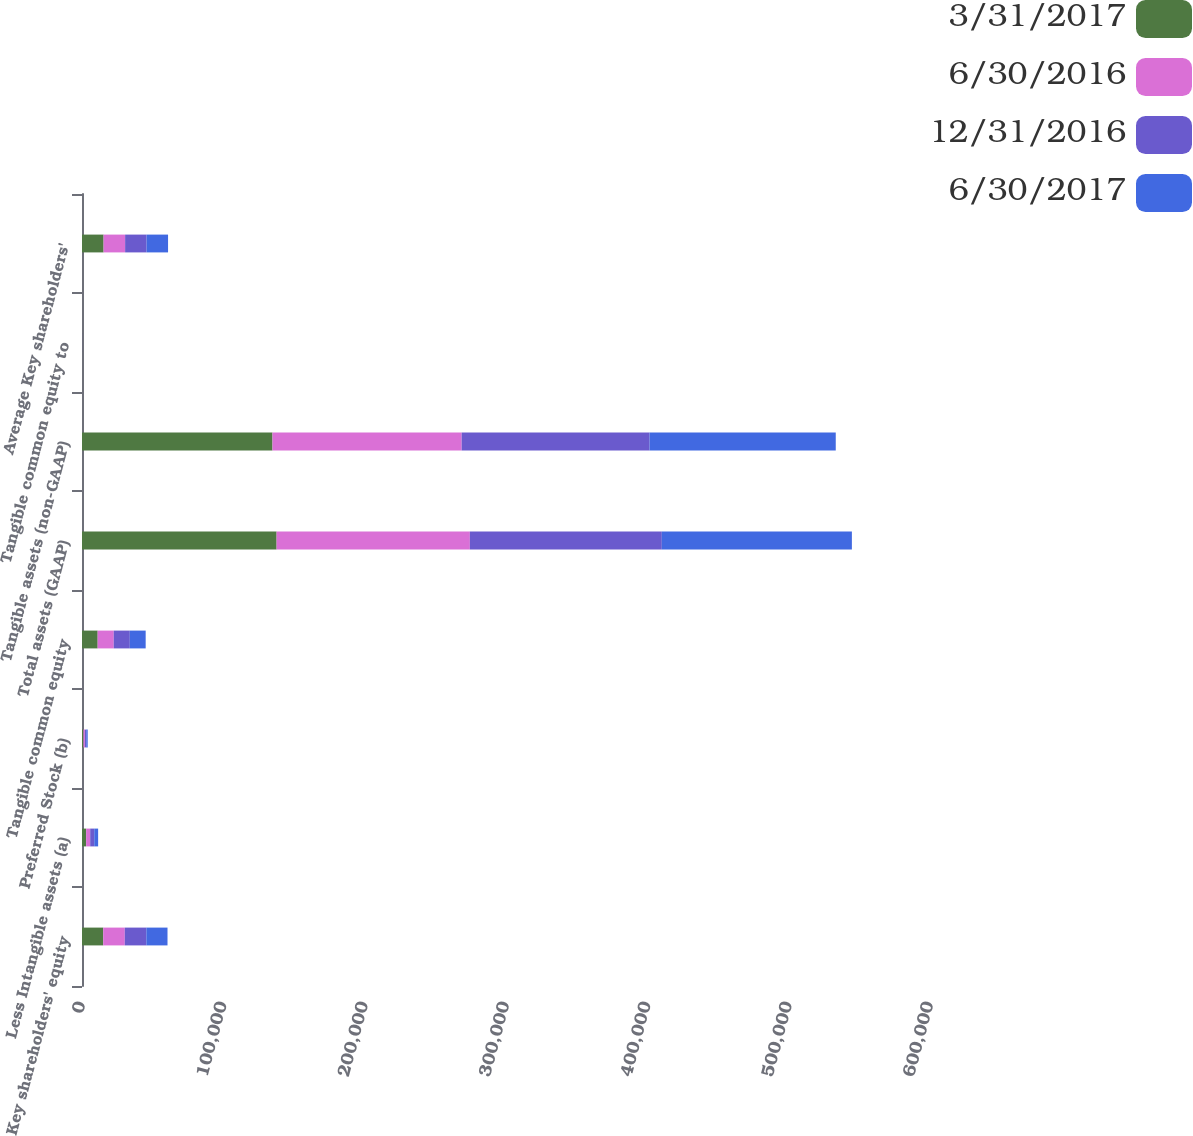Convert chart. <chart><loc_0><loc_0><loc_500><loc_500><stacked_bar_chart><ecel><fcel>Key shareholders' equity<fcel>Less Intangible assets (a)<fcel>Preferred Stock (b)<fcel>Tangible common equity<fcel>Total assets (GAAP)<fcel>Tangible assets (non-GAAP)<fcel>Tangible common equity to<fcel>Average Key shareholders'<nl><fcel>3/31/2017<fcel>15023<fcel>2928<fcel>1009<fcel>11086<fcel>137698<fcel>134770<fcel>8.23<fcel>15268<nl><fcel>6/30/2016<fcel>15249<fcel>2870<fcel>1009<fcel>11370<fcel>136733<fcel>133863<fcel>8.49<fcel>15241<nl><fcel>12/31/2016<fcel>15253<fcel>2866<fcel>1009<fcel>11378<fcel>135824<fcel>132958<fcel>8.56<fcel>15200<nl><fcel>6/30/2017<fcel>14976<fcel>2751<fcel>1009<fcel>11216<fcel>134476<fcel>131725<fcel>8.51<fcel>15184<nl></chart> 